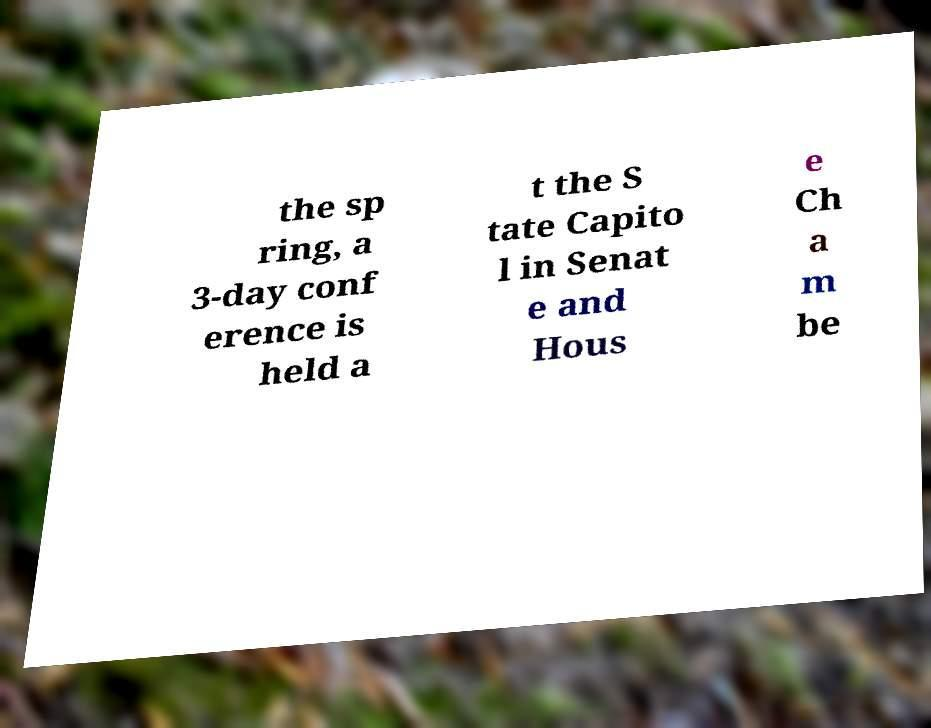There's text embedded in this image that I need extracted. Can you transcribe it verbatim? the sp ring, a 3-day conf erence is held a t the S tate Capito l in Senat e and Hous e Ch a m be 